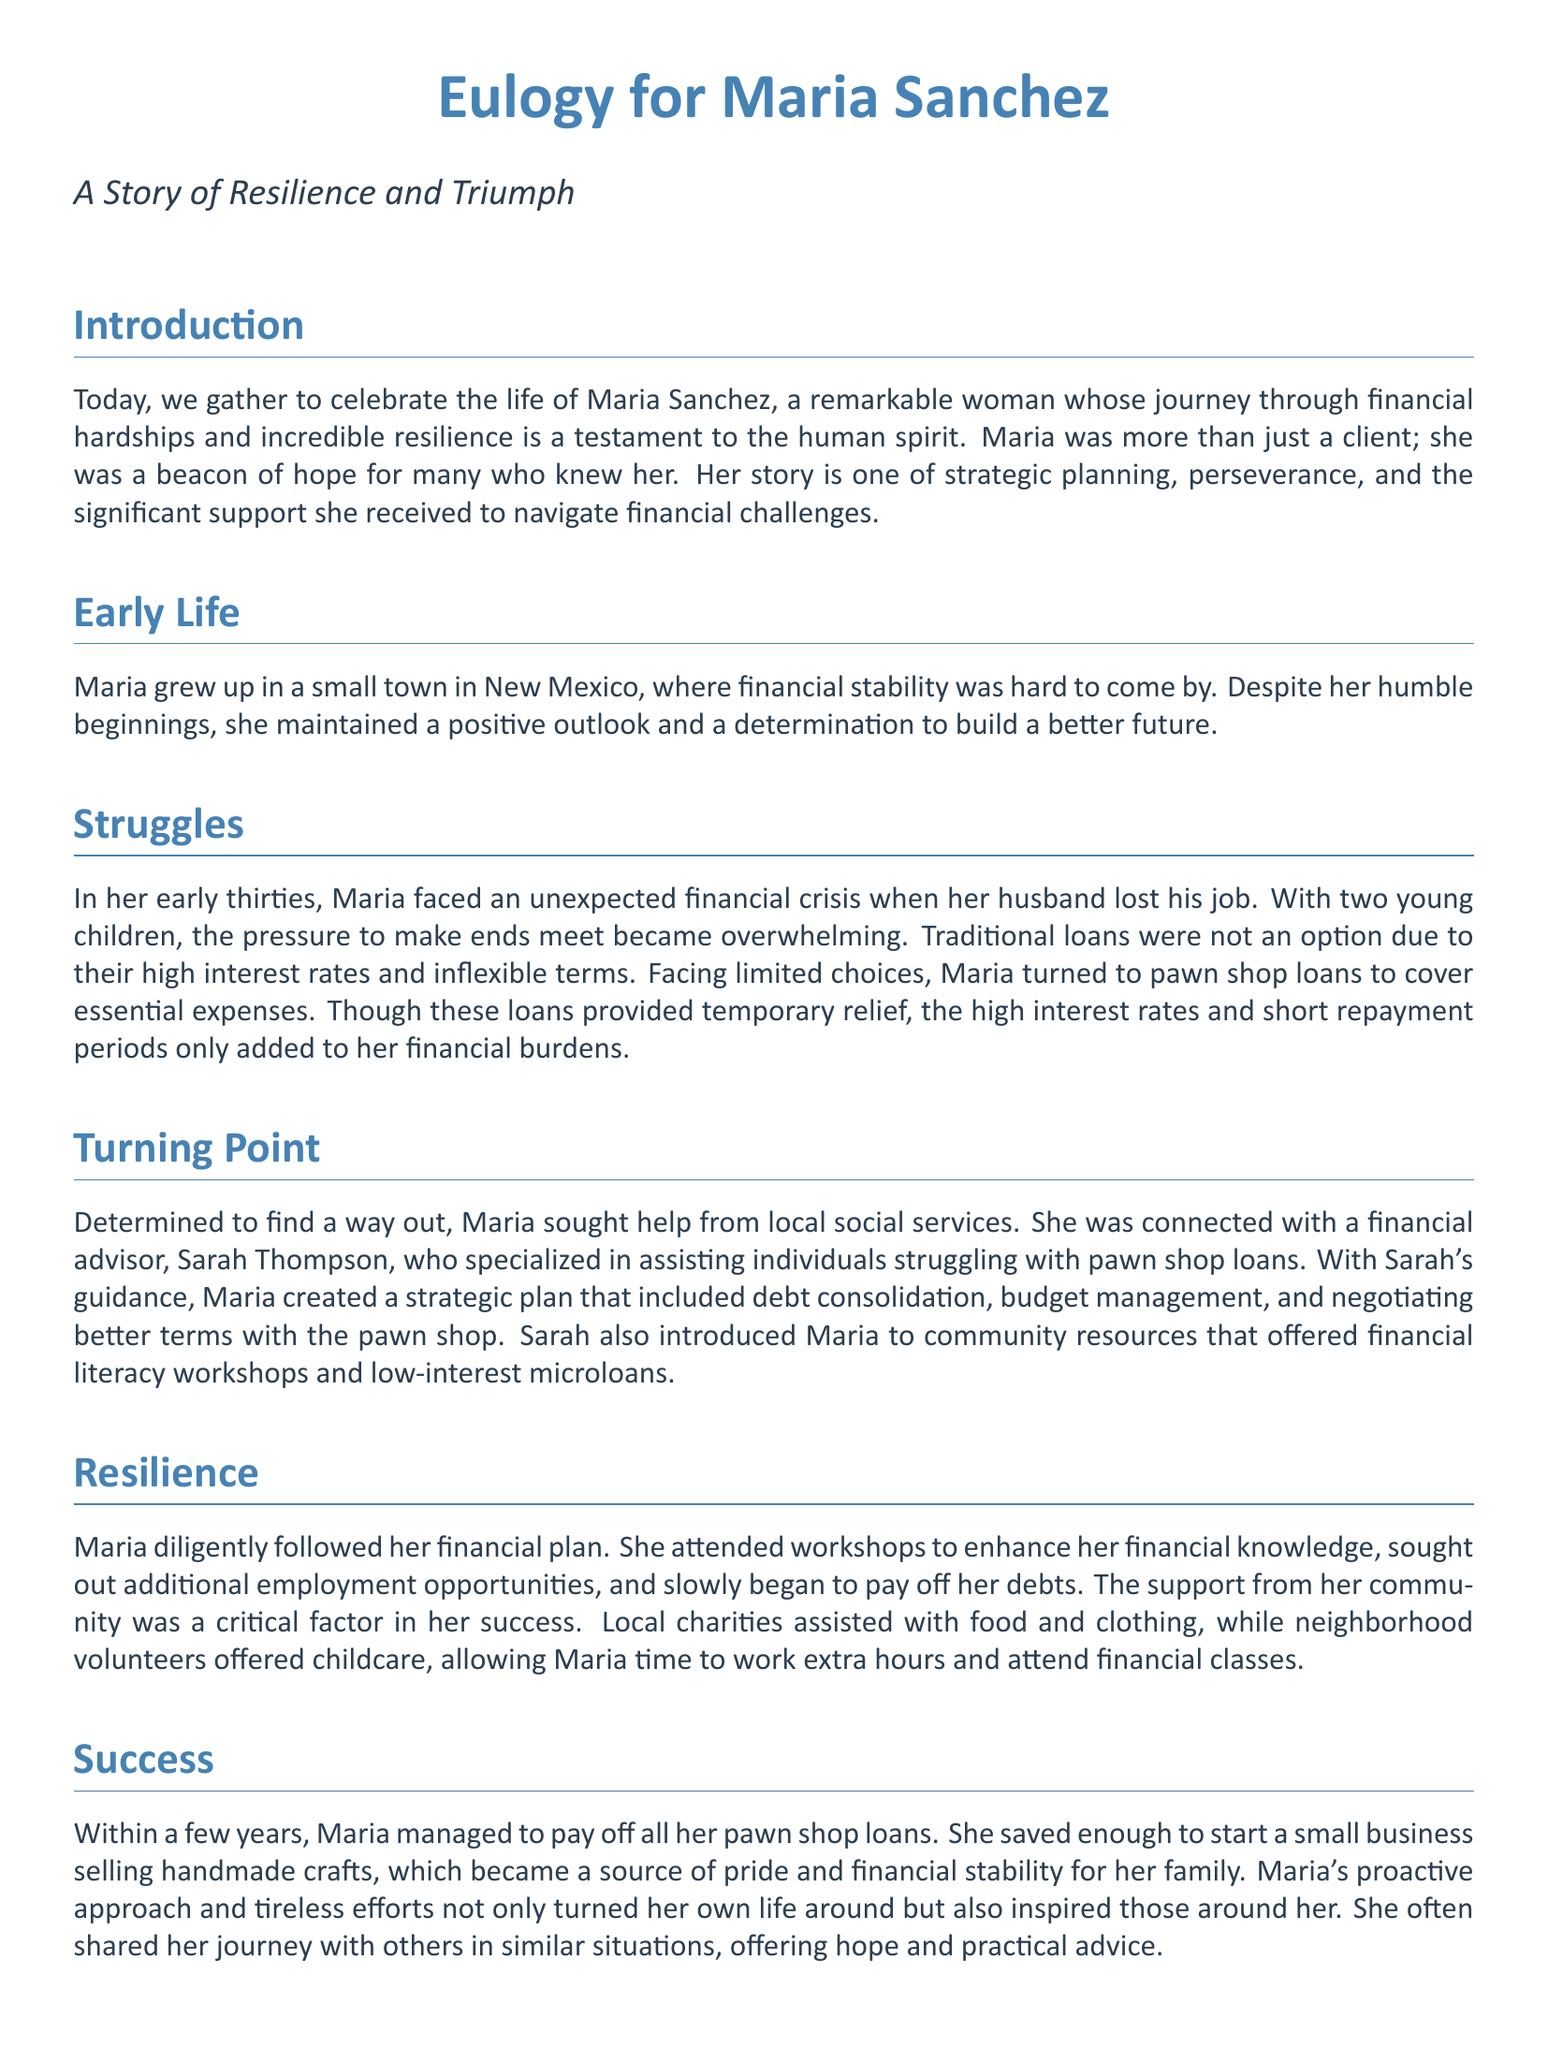what is the full name of the person being eulogized? The document clearly states the person's full name at the beginning of the eulogy.
Answer: Maria Sanchez where did Maria grow up? The eulogy mentions the location of Maria's early life, providing context about her background.
Answer: New Mexico what financial issue did Maria face in her early thirties? The document outlines the major financial crisis that occurred during Maria's early thirties.
Answer: Husband lost his job who provided financial guidance to Maria? The eulogy specifies the individual who helped Maria create a financial plan.
Answer: Sarah Thompson which type of shop did Maria initially turn to for loans? The document describes the type of business that provided Maria with initial financial support.
Answer: Pawn shop how long did it take for Maria to pay off her loans? The document indicates the duration it took for Maria to overcome her financial challenges.
Answer: A few years what small business did Maria start? The eulogy mentions the kind of business that Maria established after overcoming her financial difficulties.
Answer: Handmade crafts what was a key factor in Maria's success? The document identifies an essential element that significantly contributed to Maria's accomplishments.
Answer: Community support 